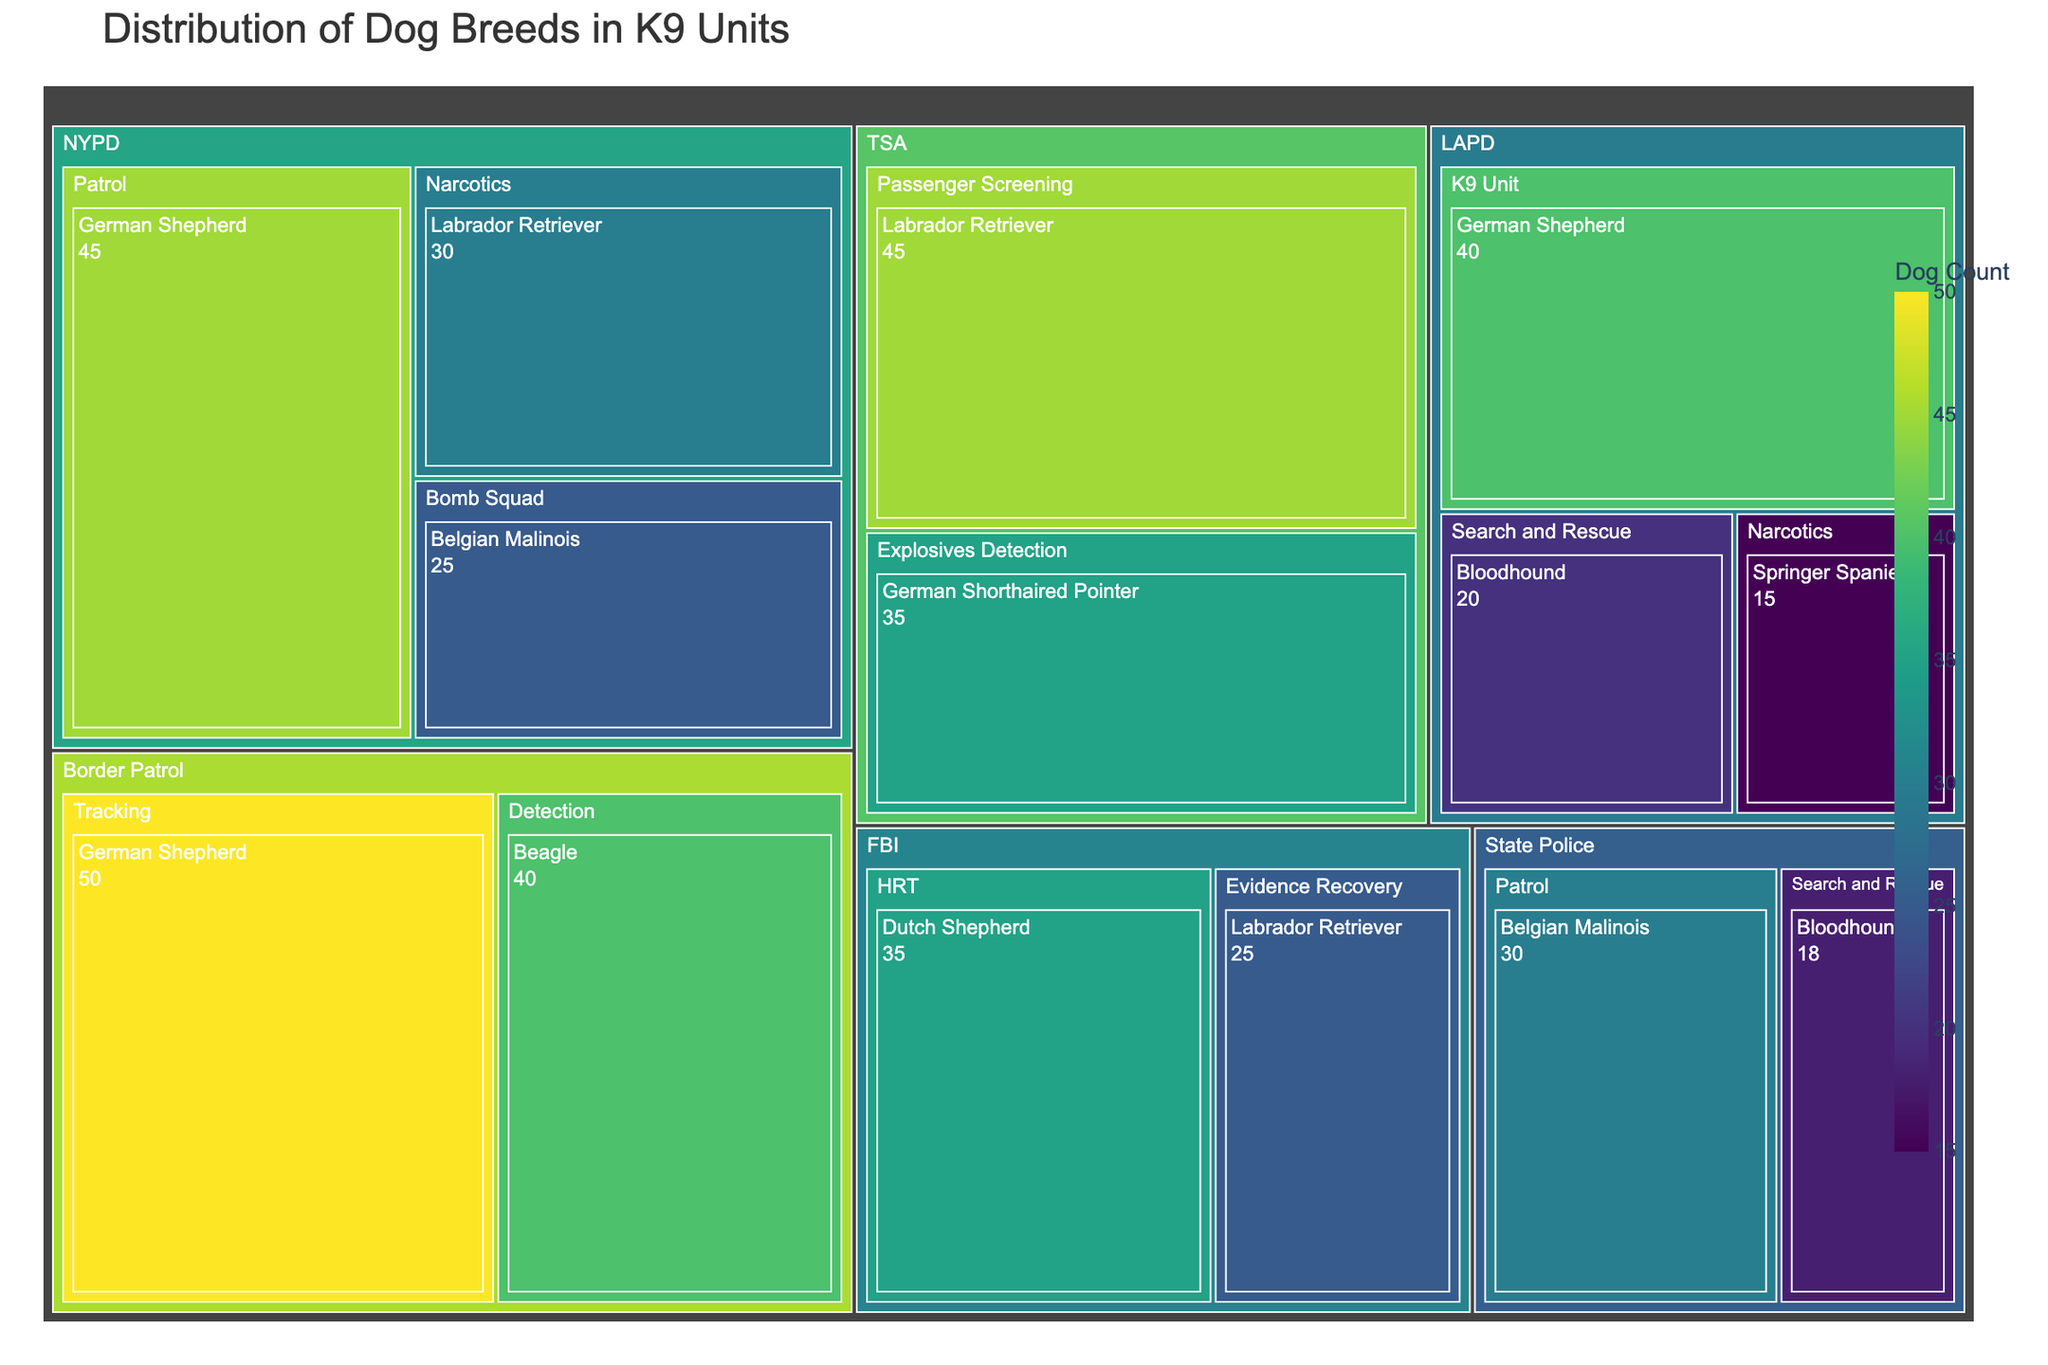What is the title of the treemap? The title is usually a prominent text that is larger in size and often located at the top of the figure. In this case, we know the title from the provided code.
Answer: Distribution of Dog Breeds in K9 Units Which agency has the highest count of dogs in the Patrol division? Look at the different divisions within each agency and identify the Patrol division. Then, compare the counts of the Patrol division across all agencies.
Answer: Border Patrol How many Belgian Malinois dogs are used across all agencies? Check for all instances of the Belgian Malinois breed across different divisions and agencies, and sum their counts. The examples provided mention Belgian Malinois in NYPD and State Police.
Answer: 55 Which breed has the highest count within the TSA? Look for the TSA section in the treemap, check the counts listed for each breed under it, and identify the highest one.
Answer: Labrador Retriever Compare the total number of dogs used by NYPD and LAPD. Which agency has more? Sum up the counts of all dog breeds used by NYPD and compare it with the total for LAPD.
Answer: NYPD What is the total count of all the dogs used in the Narcotics divisions across all agencies? Locate the Narcotics division within each relevant agency and sum their dog counts. The mentioned agencies are NYPD and LAPD.
Answer: 45 How many breeds are used by the Border Patrol? Look at the Border Patrol section and count the distinct breeds listed.
Answer: 2 Which division within the FBI uses Dutch Shepherds? Look specifically under the FBI section and identify which division lists Dutch Shepherds.
Answer: HRT Compare the number of Bloodhounds used by LAPD and State Police. Which one has fewer Bloodhounds and by how much? Identify the count of Bloodhounds in the LAPD and State Police sections, subtract the smaller count from the larger count to determine the difference.
Answer: State Police, by 2 In which agency is the Springer Spaniel breed used, and for what purpose? Locate the section for Springer Spaniel and identify the agency and division or purpose listed under it.
Answer: LAPD, Narcotics 